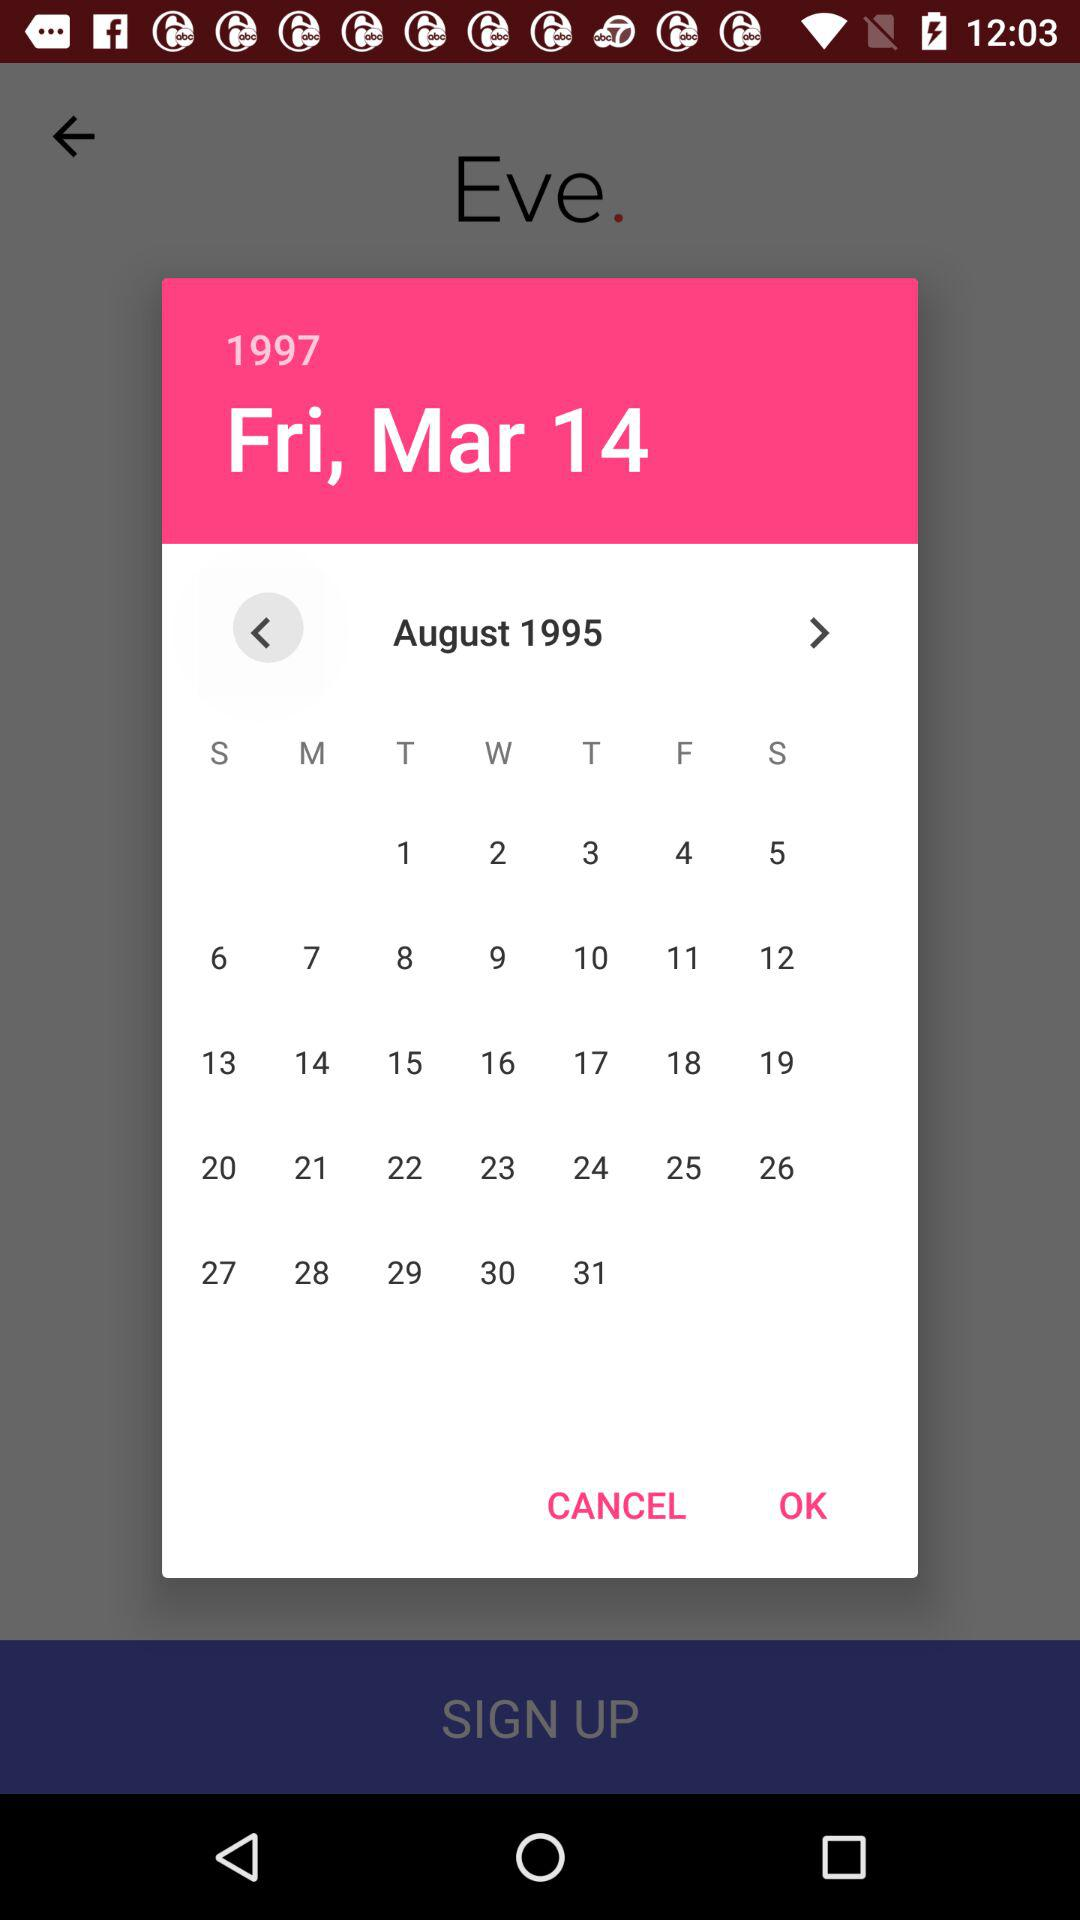What was the selected date? The selected date was Friday, March 14, 1997. 